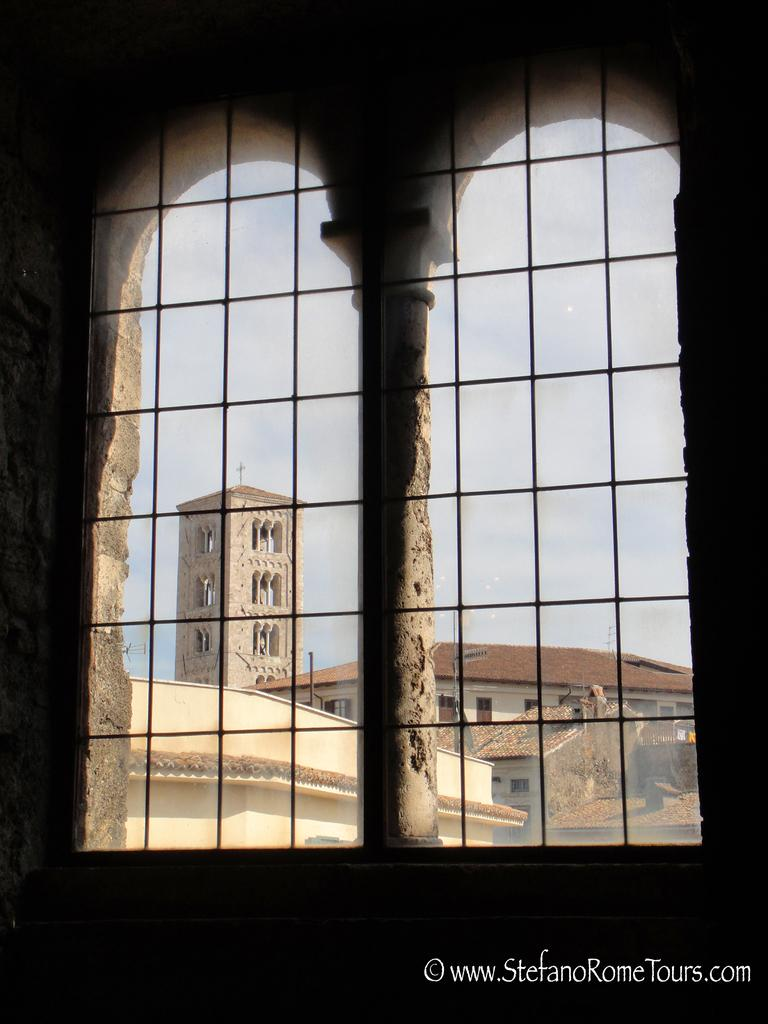What type of objects can be seen in the image? There are metal rods in the image. What else is visible in the image besides the metal rods? There are buildings in the image. Is there any additional information or marking present in the image? Yes, there is a watermark at the right bottom of the image. What type of engine can be seen in the image? There is no engine present in the image; it features metal rods and buildings. What type of liquid is visible in the image? There is no liquid visible in the image. 